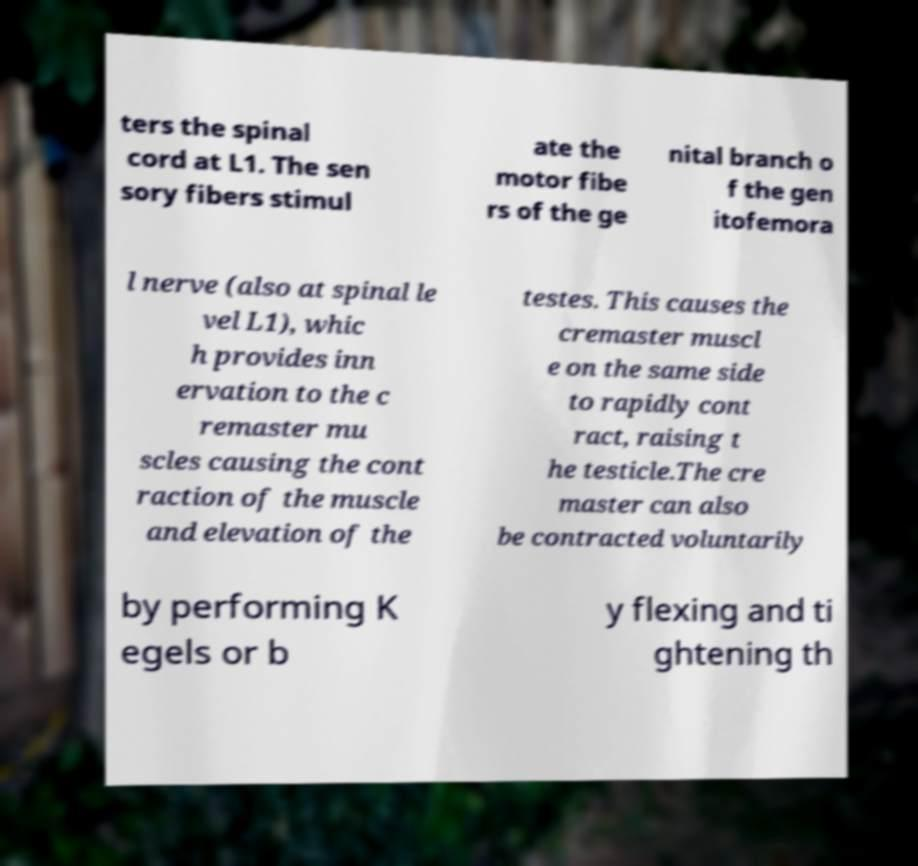Please identify and transcribe the text found in this image. ters the spinal cord at L1. The sen sory fibers stimul ate the motor fibe rs of the ge nital branch o f the gen itofemora l nerve (also at spinal le vel L1), whic h provides inn ervation to the c remaster mu scles causing the cont raction of the muscle and elevation of the testes. This causes the cremaster muscl e on the same side to rapidly cont ract, raising t he testicle.The cre master can also be contracted voluntarily by performing K egels or b y flexing and ti ghtening th 